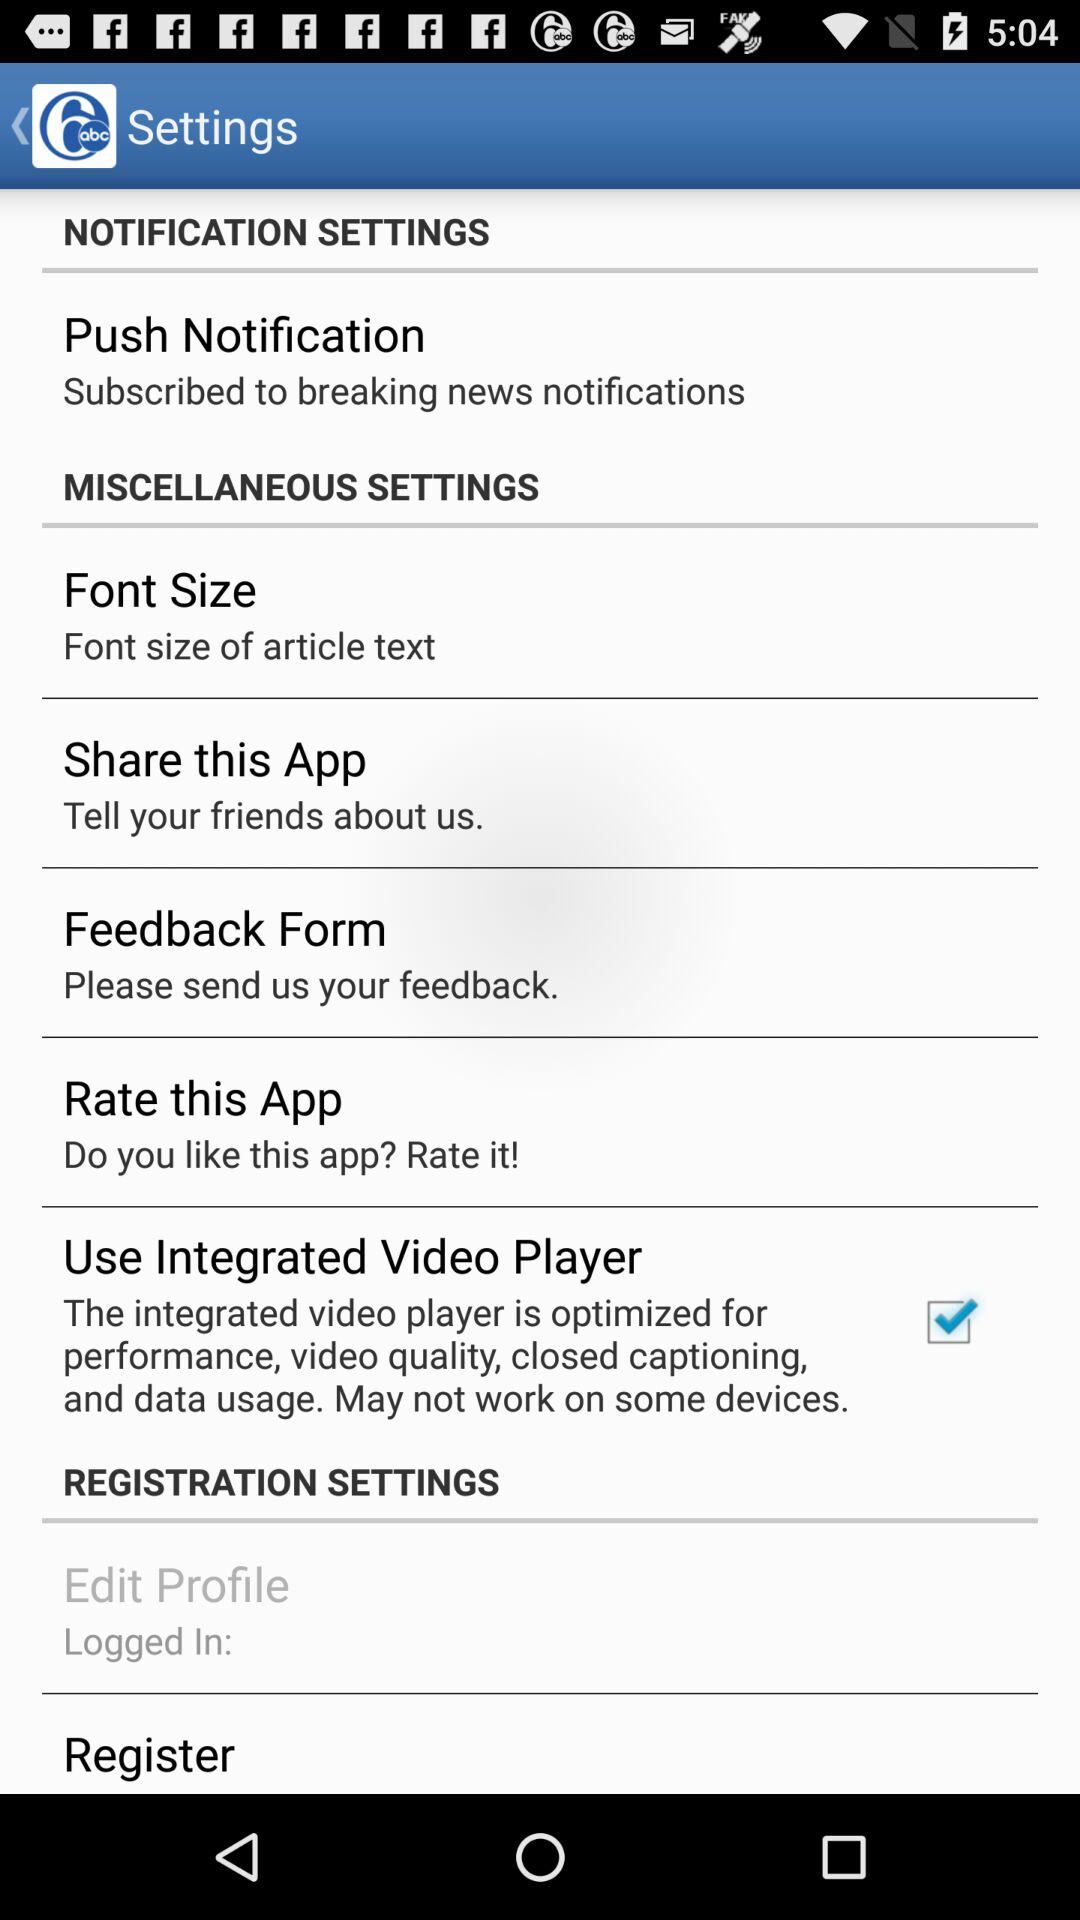What's the font size?
When the provided information is insufficient, respond with <no answer>. <no answer> 